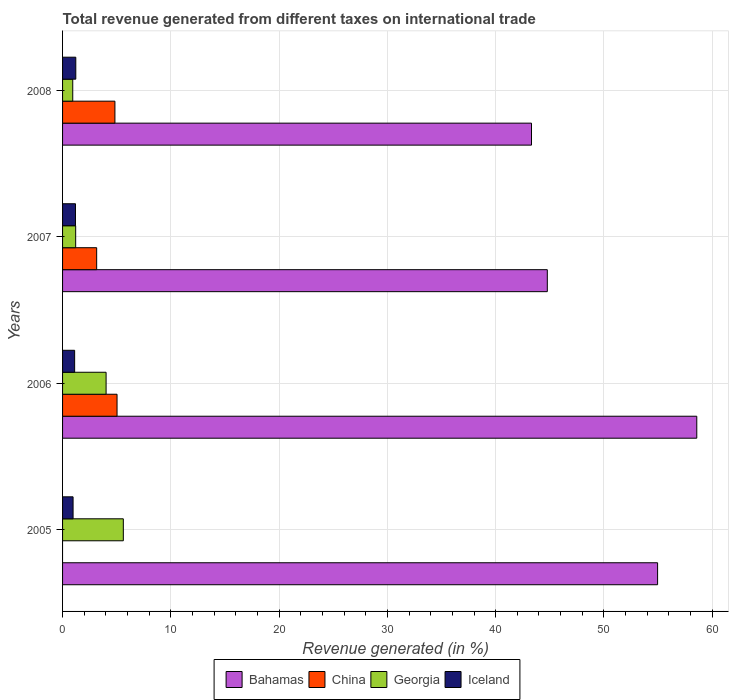How many groups of bars are there?
Ensure brevity in your answer.  4. Are the number of bars per tick equal to the number of legend labels?
Your response must be concise. No. How many bars are there on the 4th tick from the bottom?
Give a very brief answer. 4. What is the label of the 4th group of bars from the top?
Keep it short and to the point. 2005. In how many cases, is the number of bars for a given year not equal to the number of legend labels?
Ensure brevity in your answer.  1. What is the total revenue generated in Bahamas in 2006?
Your response must be concise. 58.58. Across all years, what is the maximum total revenue generated in Bahamas?
Ensure brevity in your answer.  58.58. Across all years, what is the minimum total revenue generated in Georgia?
Your answer should be compact. 0.94. In which year was the total revenue generated in Bahamas maximum?
Your response must be concise. 2006. What is the total total revenue generated in Iceland in the graph?
Provide a short and direct response. 4.5. What is the difference between the total revenue generated in Bahamas in 2005 and that in 2008?
Your answer should be compact. 11.65. What is the difference between the total revenue generated in China in 2005 and the total revenue generated in Iceland in 2007?
Make the answer very short. -1.19. What is the average total revenue generated in Iceland per year?
Keep it short and to the point. 1.13. In the year 2008, what is the difference between the total revenue generated in China and total revenue generated in Iceland?
Your answer should be very brief. 3.61. In how many years, is the total revenue generated in China greater than 6 %?
Your answer should be very brief. 0. What is the ratio of the total revenue generated in Georgia in 2006 to that in 2008?
Offer a terse response. 4.27. Is the difference between the total revenue generated in China in 2006 and 2007 greater than the difference between the total revenue generated in Iceland in 2006 and 2007?
Give a very brief answer. Yes. What is the difference between the highest and the second highest total revenue generated in China?
Give a very brief answer. 0.2. What is the difference between the highest and the lowest total revenue generated in Bahamas?
Your response must be concise. 15.27. In how many years, is the total revenue generated in Georgia greater than the average total revenue generated in Georgia taken over all years?
Provide a succinct answer. 2. Is the sum of the total revenue generated in Georgia in 2005 and 2006 greater than the maximum total revenue generated in China across all years?
Give a very brief answer. Yes. Is it the case that in every year, the sum of the total revenue generated in Georgia and total revenue generated in Bahamas is greater than the sum of total revenue generated in China and total revenue generated in Iceland?
Your answer should be very brief. Yes. Is it the case that in every year, the sum of the total revenue generated in China and total revenue generated in Georgia is greater than the total revenue generated in Bahamas?
Your answer should be compact. No. How many bars are there?
Provide a succinct answer. 15. How many years are there in the graph?
Provide a short and direct response. 4. Does the graph contain any zero values?
Provide a succinct answer. Yes. Does the graph contain grids?
Your answer should be very brief. Yes. Where does the legend appear in the graph?
Offer a very short reply. Bottom center. How are the legend labels stacked?
Provide a short and direct response. Horizontal. What is the title of the graph?
Your response must be concise. Total revenue generated from different taxes on international trade. Does "Low & middle income" appear as one of the legend labels in the graph?
Ensure brevity in your answer.  No. What is the label or title of the X-axis?
Offer a very short reply. Revenue generated (in %). What is the label or title of the Y-axis?
Ensure brevity in your answer.  Years. What is the Revenue generated (in %) in Bahamas in 2005?
Offer a terse response. 54.96. What is the Revenue generated (in %) of Georgia in 2005?
Ensure brevity in your answer.  5.61. What is the Revenue generated (in %) of Iceland in 2005?
Provide a short and direct response. 0.97. What is the Revenue generated (in %) in Bahamas in 2006?
Give a very brief answer. 58.58. What is the Revenue generated (in %) in China in 2006?
Your response must be concise. 5.03. What is the Revenue generated (in %) of Georgia in 2006?
Make the answer very short. 4.02. What is the Revenue generated (in %) of Iceland in 2006?
Provide a short and direct response. 1.12. What is the Revenue generated (in %) in Bahamas in 2007?
Offer a terse response. 44.77. What is the Revenue generated (in %) in China in 2007?
Make the answer very short. 3.15. What is the Revenue generated (in %) in Georgia in 2007?
Your response must be concise. 1.21. What is the Revenue generated (in %) of Iceland in 2007?
Keep it short and to the point. 1.19. What is the Revenue generated (in %) of Bahamas in 2008?
Provide a short and direct response. 43.31. What is the Revenue generated (in %) in China in 2008?
Give a very brief answer. 4.84. What is the Revenue generated (in %) in Georgia in 2008?
Your answer should be compact. 0.94. What is the Revenue generated (in %) of Iceland in 2008?
Make the answer very short. 1.22. Across all years, what is the maximum Revenue generated (in %) in Bahamas?
Your answer should be very brief. 58.58. Across all years, what is the maximum Revenue generated (in %) of China?
Your answer should be very brief. 5.03. Across all years, what is the maximum Revenue generated (in %) of Georgia?
Provide a succinct answer. 5.61. Across all years, what is the maximum Revenue generated (in %) in Iceland?
Make the answer very short. 1.22. Across all years, what is the minimum Revenue generated (in %) in Bahamas?
Your response must be concise. 43.31. Across all years, what is the minimum Revenue generated (in %) of Georgia?
Provide a short and direct response. 0.94. Across all years, what is the minimum Revenue generated (in %) of Iceland?
Your answer should be compact. 0.97. What is the total Revenue generated (in %) in Bahamas in the graph?
Your answer should be compact. 201.62. What is the total Revenue generated (in %) of China in the graph?
Your answer should be compact. 13.02. What is the total Revenue generated (in %) in Georgia in the graph?
Your answer should be very brief. 11.78. What is the total Revenue generated (in %) of Iceland in the graph?
Keep it short and to the point. 4.5. What is the difference between the Revenue generated (in %) of Bahamas in 2005 and that in 2006?
Give a very brief answer. -3.62. What is the difference between the Revenue generated (in %) in Georgia in 2005 and that in 2006?
Provide a succinct answer. 1.59. What is the difference between the Revenue generated (in %) of Iceland in 2005 and that in 2006?
Offer a very short reply. -0.14. What is the difference between the Revenue generated (in %) of Bahamas in 2005 and that in 2007?
Your answer should be very brief. 10.19. What is the difference between the Revenue generated (in %) in Georgia in 2005 and that in 2007?
Keep it short and to the point. 4.4. What is the difference between the Revenue generated (in %) of Iceland in 2005 and that in 2007?
Give a very brief answer. -0.22. What is the difference between the Revenue generated (in %) in Bahamas in 2005 and that in 2008?
Provide a short and direct response. 11.65. What is the difference between the Revenue generated (in %) of Georgia in 2005 and that in 2008?
Offer a very short reply. 4.67. What is the difference between the Revenue generated (in %) in Iceland in 2005 and that in 2008?
Offer a terse response. -0.25. What is the difference between the Revenue generated (in %) of Bahamas in 2006 and that in 2007?
Offer a very short reply. 13.81. What is the difference between the Revenue generated (in %) of China in 2006 and that in 2007?
Provide a succinct answer. 1.88. What is the difference between the Revenue generated (in %) in Georgia in 2006 and that in 2007?
Your answer should be compact. 2.81. What is the difference between the Revenue generated (in %) in Iceland in 2006 and that in 2007?
Ensure brevity in your answer.  -0.08. What is the difference between the Revenue generated (in %) of Bahamas in 2006 and that in 2008?
Make the answer very short. 15.27. What is the difference between the Revenue generated (in %) of China in 2006 and that in 2008?
Your answer should be very brief. 0.2. What is the difference between the Revenue generated (in %) of Georgia in 2006 and that in 2008?
Your answer should be compact. 3.08. What is the difference between the Revenue generated (in %) of Iceland in 2006 and that in 2008?
Your answer should be very brief. -0.11. What is the difference between the Revenue generated (in %) in Bahamas in 2007 and that in 2008?
Keep it short and to the point. 1.46. What is the difference between the Revenue generated (in %) of China in 2007 and that in 2008?
Give a very brief answer. -1.69. What is the difference between the Revenue generated (in %) in Georgia in 2007 and that in 2008?
Give a very brief answer. 0.27. What is the difference between the Revenue generated (in %) of Iceland in 2007 and that in 2008?
Keep it short and to the point. -0.03. What is the difference between the Revenue generated (in %) of Bahamas in 2005 and the Revenue generated (in %) of China in 2006?
Provide a short and direct response. 49.93. What is the difference between the Revenue generated (in %) of Bahamas in 2005 and the Revenue generated (in %) of Georgia in 2006?
Provide a succinct answer. 50.94. What is the difference between the Revenue generated (in %) of Bahamas in 2005 and the Revenue generated (in %) of Iceland in 2006?
Provide a succinct answer. 53.84. What is the difference between the Revenue generated (in %) of Georgia in 2005 and the Revenue generated (in %) of Iceland in 2006?
Provide a short and direct response. 4.5. What is the difference between the Revenue generated (in %) in Bahamas in 2005 and the Revenue generated (in %) in China in 2007?
Provide a short and direct response. 51.81. What is the difference between the Revenue generated (in %) of Bahamas in 2005 and the Revenue generated (in %) of Georgia in 2007?
Give a very brief answer. 53.75. What is the difference between the Revenue generated (in %) of Bahamas in 2005 and the Revenue generated (in %) of Iceland in 2007?
Your answer should be compact. 53.76. What is the difference between the Revenue generated (in %) in Georgia in 2005 and the Revenue generated (in %) in Iceland in 2007?
Keep it short and to the point. 4.42. What is the difference between the Revenue generated (in %) in Bahamas in 2005 and the Revenue generated (in %) in China in 2008?
Offer a terse response. 50.12. What is the difference between the Revenue generated (in %) of Bahamas in 2005 and the Revenue generated (in %) of Georgia in 2008?
Your response must be concise. 54.02. What is the difference between the Revenue generated (in %) in Bahamas in 2005 and the Revenue generated (in %) in Iceland in 2008?
Your answer should be very brief. 53.74. What is the difference between the Revenue generated (in %) in Georgia in 2005 and the Revenue generated (in %) in Iceland in 2008?
Provide a succinct answer. 4.39. What is the difference between the Revenue generated (in %) in Bahamas in 2006 and the Revenue generated (in %) in China in 2007?
Give a very brief answer. 55.43. What is the difference between the Revenue generated (in %) of Bahamas in 2006 and the Revenue generated (in %) of Georgia in 2007?
Your response must be concise. 57.37. What is the difference between the Revenue generated (in %) in Bahamas in 2006 and the Revenue generated (in %) in Iceland in 2007?
Make the answer very short. 57.38. What is the difference between the Revenue generated (in %) of China in 2006 and the Revenue generated (in %) of Georgia in 2007?
Provide a short and direct response. 3.82. What is the difference between the Revenue generated (in %) of China in 2006 and the Revenue generated (in %) of Iceland in 2007?
Your response must be concise. 3.84. What is the difference between the Revenue generated (in %) of Georgia in 2006 and the Revenue generated (in %) of Iceland in 2007?
Provide a succinct answer. 2.83. What is the difference between the Revenue generated (in %) in Bahamas in 2006 and the Revenue generated (in %) in China in 2008?
Offer a terse response. 53.74. What is the difference between the Revenue generated (in %) of Bahamas in 2006 and the Revenue generated (in %) of Georgia in 2008?
Provide a succinct answer. 57.64. What is the difference between the Revenue generated (in %) of Bahamas in 2006 and the Revenue generated (in %) of Iceland in 2008?
Keep it short and to the point. 57.35. What is the difference between the Revenue generated (in %) in China in 2006 and the Revenue generated (in %) in Georgia in 2008?
Keep it short and to the point. 4.09. What is the difference between the Revenue generated (in %) of China in 2006 and the Revenue generated (in %) of Iceland in 2008?
Give a very brief answer. 3.81. What is the difference between the Revenue generated (in %) of Georgia in 2006 and the Revenue generated (in %) of Iceland in 2008?
Ensure brevity in your answer.  2.8. What is the difference between the Revenue generated (in %) of Bahamas in 2007 and the Revenue generated (in %) of China in 2008?
Your response must be concise. 39.94. What is the difference between the Revenue generated (in %) in Bahamas in 2007 and the Revenue generated (in %) in Georgia in 2008?
Ensure brevity in your answer.  43.83. What is the difference between the Revenue generated (in %) in Bahamas in 2007 and the Revenue generated (in %) in Iceland in 2008?
Your response must be concise. 43.55. What is the difference between the Revenue generated (in %) in China in 2007 and the Revenue generated (in %) in Georgia in 2008?
Your answer should be compact. 2.21. What is the difference between the Revenue generated (in %) of China in 2007 and the Revenue generated (in %) of Iceland in 2008?
Offer a terse response. 1.93. What is the difference between the Revenue generated (in %) in Georgia in 2007 and the Revenue generated (in %) in Iceland in 2008?
Ensure brevity in your answer.  -0.01. What is the average Revenue generated (in %) in Bahamas per year?
Your answer should be very brief. 50.4. What is the average Revenue generated (in %) in China per year?
Provide a succinct answer. 3.25. What is the average Revenue generated (in %) in Georgia per year?
Your response must be concise. 2.95. What is the average Revenue generated (in %) of Iceland per year?
Your answer should be compact. 1.13. In the year 2005, what is the difference between the Revenue generated (in %) in Bahamas and Revenue generated (in %) in Georgia?
Make the answer very short. 49.35. In the year 2005, what is the difference between the Revenue generated (in %) of Bahamas and Revenue generated (in %) of Iceland?
Keep it short and to the point. 53.99. In the year 2005, what is the difference between the Revenue generated (in %) of Georgia and Revenue generated (in %) of Iceland?
Ensure brevity in your answer.  4.64. In the year 2006, what is the difference between the Revenue generated (in %) of Bahamas and Revenue generated (in %) of China?
Provide a succinct answer. 53.55. In the year 2006, what is the difference between the Revenue generated (in %) in Bahamas and Revenue generated (in %) in Georgia?
Give a very brief answer. 54.56. In the year 2006, what is the difference between the Revenue generated (in %) of Bahamas and Revenue generated (in %) of Iceland?
Your answer should be very brief. 57.46. In the year 2006, what is the difference between the Revenue generated (in %) of China and Revenue generated (in %) of Georgia?
Make the answer very short. 1.01. In the year 2006, what is the difference between the Revenue generated (in %) in China and Revenue generated (in %) in Iceland?
Your answer should be very brief. 3.92. In the year 2006, what is the difference between the Revenue generated (in %) of Georgia and Revenue generated (in %) of Iceland?
Your response must be concise. 2.9. In the year 2007, what is the difference between the Revenue generated (in %) of Bahamas and Revenue generated (in %) of China?
Your answer should be very brief. 41.62. In the year 2007, what is the difference between the Revenue generated (in %) in Bahamas and Revenue generated (in %) in Georgia?
Offer a terse response. 43.56. In the year 2007, what is the difference between the Revenue generated (in %) in Bahamas and Revenue generated (in %) in Iceland?
Provide a succinct answer. 43.58. In the year 2007, what is the difference between the Revenue generated (in %) of China and Revenue generated (in %) of Georgia?
Your answer should be very brief. 1.94. In the year 2007, what is the difference between the Revenue generated (in %) in China and Revenue generated (in %) in Iceland?
Offer a very short reply. 1.96. In the year 2007, what is the difference between the Revenue generated (in %) of Georgia and Revenue generated (in %) of Iceland?
Make the answer very short. 0.02. In the year 2008, what is the difference between the Revenue generated (in %) in Bahamas and Revenue generated (in %) in China?
Provide a short and direct response. 38.48. In the year 2008, what is the difference between the Revenue generated (in %) in Bahamas and Revenue generated (in %) in Georgia?
Offer a very short reply. 42.37. In the year 2008, what is the difference between the Revenue generated (in %) of Bahamas and Revenue generated (in %) of Iceland?
Keep it short and to the point. 42.09. In the year 2008, what is the difference between the Revenue generated (in %) of China and Revenue generated (in %) of Georgia?
Offer a terse response. 3.9. In the year 2008, what is the difference between the Revenue generated (in %) in China and Revenue generated (in %) in Iceland?
Give a very brief answer. 3.61. In the year 2008, what is the difference between the Revenue generated (in %) in Georgia and Revenue generated (in %) in Iceland?
Your answer should be very brief. -0.28. What is the ratio of the Revenue generated (in %) of Bahamas in 2005 to that in 2006?
Give a very brief answer. 0.94. What is the ratio of the Revenue generated (in %) of Georgia in 2005 to that in 2006?
Your answer should be compact. 1.4. What is the ratio of the Revenue generated (in %) in Iceland in 2005 to that in 2006?
Provide a succinct answer. 0.87. What is the ratio of the Revenue generated (in %) in Bahamas in 2005 to that in 2007?
Offer a very short reply. 1.23. What is the ratio of the Revenue generated (in %) in Georgia in 2005 to that in 2007?
Provide a short and direct response. 4.63. What is the ratio of the Revenue generated (in %) of Iceland in 2005 to that in 2007?
Ensure brevity in your answer.  0.81. What is the ratio of the Revenue generated (in %) of Bahamas in 2005 to that in 2008?
Your answer should be compact. 1.27. What is the ratio of the Revenue generated (in %) in Georgia in 2005 to that in 2008?
Keep it short and to the point. 5.97. What is the ratio of the Revenue generated (in %) in Iceland in 2005 to that in 2008?
Provide a succinct answer. 0.79. What is the ratio of the Revenue generated (in %) of Bahamas in 2006 to that in 2007?
Give a very brief answer. 1.31. What is the ratio of the Revenue generated (in %) in China in 2006 to that in 2007?
Your answer should be compact. 1.6. What is the ratio of the Revenue generated (in %) of Georgia in 2006 to that in 2007?
Your answer should be very brief. 3.32. What is the ratio of the Revenue generated (in %) of Iceland in 2006 to that in 2007?
Your answer should be compact. 0.94. What is the ratio of the Revenue generated (in %) in Bahamas in 2006 to that in 2008?
Provide a short and direct response. 1.35. What is the ratio of the Revenue generated (in %) in China in 2006 to that in 2008?
Provide a succinct answer. 1.04. What is the ratio of the Revenue generated (in %) in Georgia in 2006 to that in 2008?
Offer a terse response. 4.27. What is the ratio of the Revenue generated (in %) of Iceland in 2006 to that in 2008?
Your answer should be compact. 0.91. What is the ratio of the Revenue generated (in %) in Bahamas in 2007 to that in 2008?
Give a very brief answer. 1.03. What is the ratio of the Revenue generated (in %) of China in 2007 to that in 2008?
Your answer should be very brief. 0.65. What is the ratio of the Revenue generated (in %) of Georgia in 2007 to that in 2008?
Ensure brevity in your answer.  1.29. What is the ratio of the Revenue generated (in %) of Iceland in 2007 to that in 2008?
Your response must be concise. 0.98. What is the difference between the highest and the second highest Revenue generated (in %) of Bahamas?
Your response must be concise. 3.62. What is the difference between the highest and the second highest Revenue generated (in %) in China?
Provide a short and direct response. 0.2. What is the difference between the highest and the second highest Revenue generated (in %) of Georgia?
Your answer should be compact. 1.59. What is the difference between the highest and the second highest Revenue generated (in %) in Iceland?
Provide a succinct answer. 0.03. What is the difference between the highest and the lowest Revenue generated (in %) of Bahamas?
Provide a short and direct response. 15.27. What is the difference between the highest and the lowest Revenue generated (in %) in China?
Your response must be concise. 5.03. What is the difference between the highest and the lowest Revenue generated (in %) of Georgia?
Provide a succinct answer. 4.67. What is the difference between the highest and the lowest Revenue generated (in %) in Iceland?
Provide a short and direct response. 0.25. 